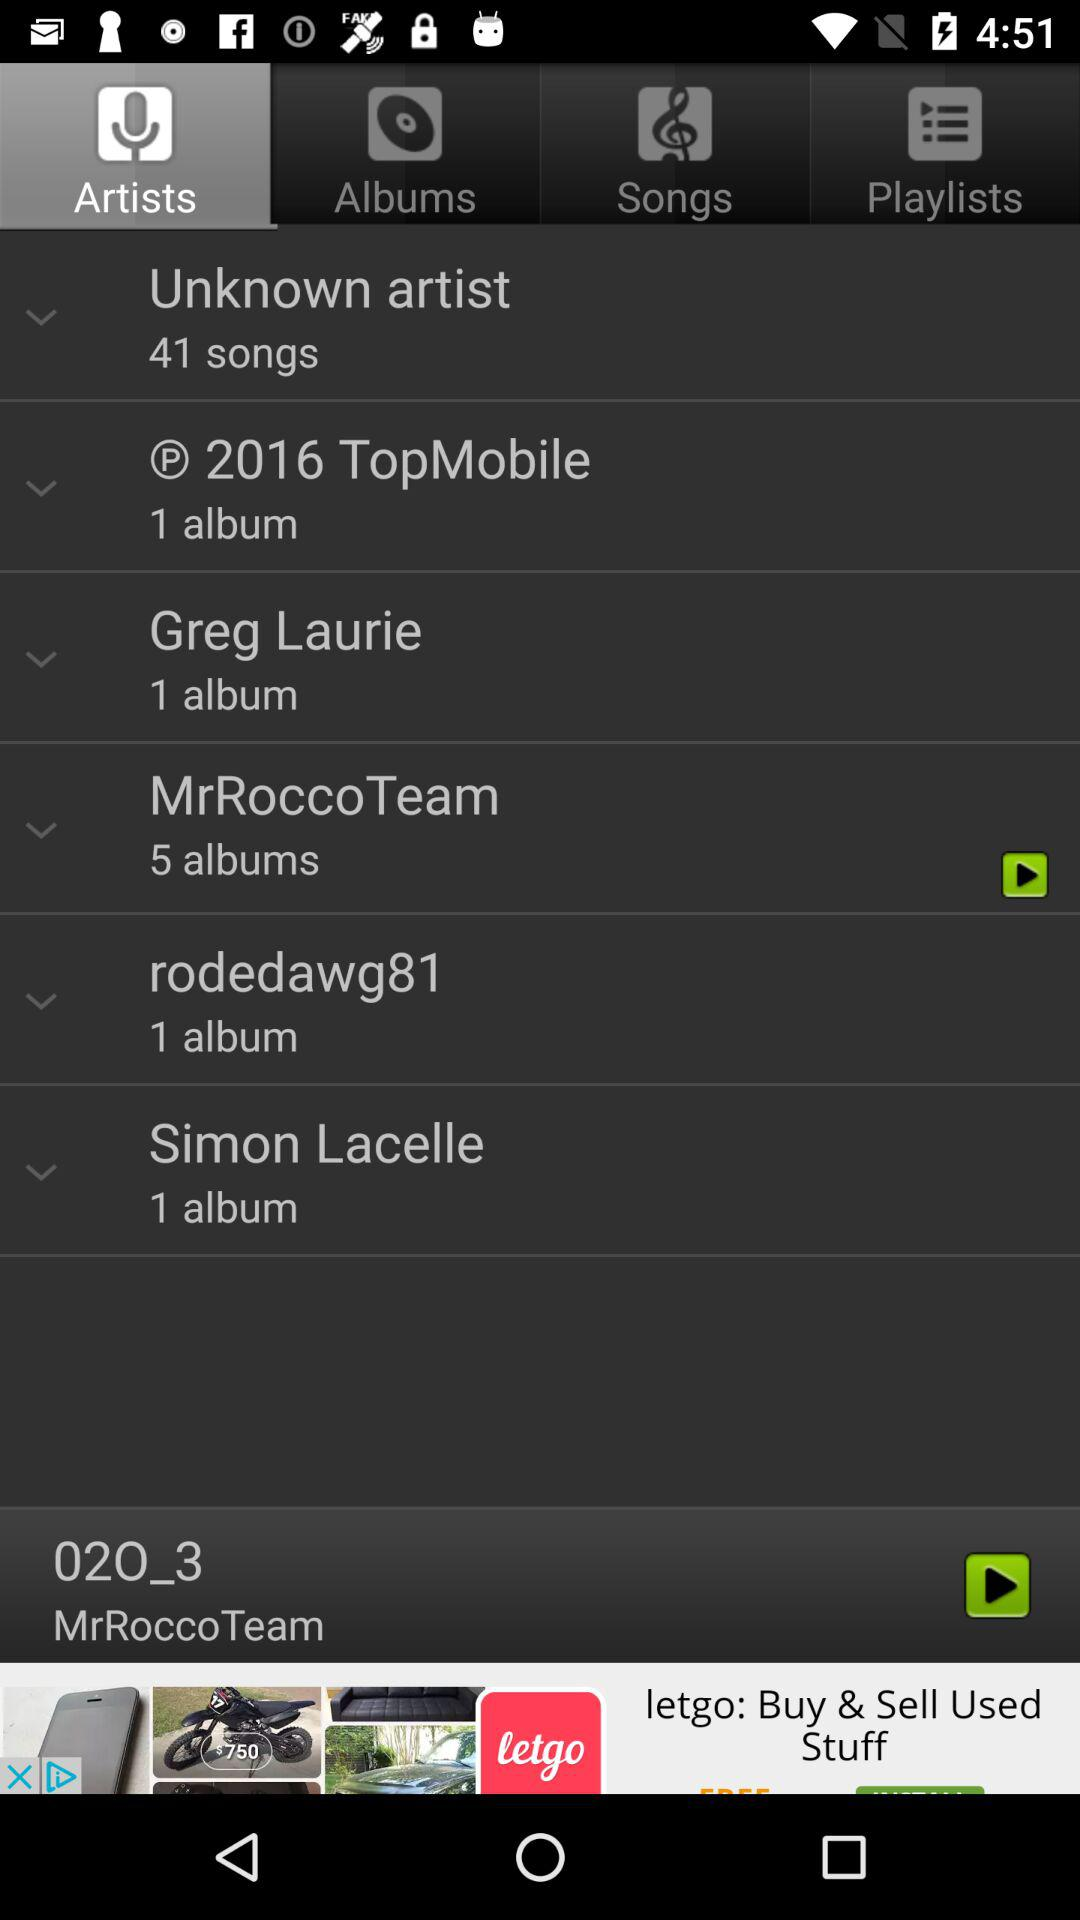How many more albums does MrRocco Team have than rodedawg81?
Answer the question using a single word or phrase. 4 